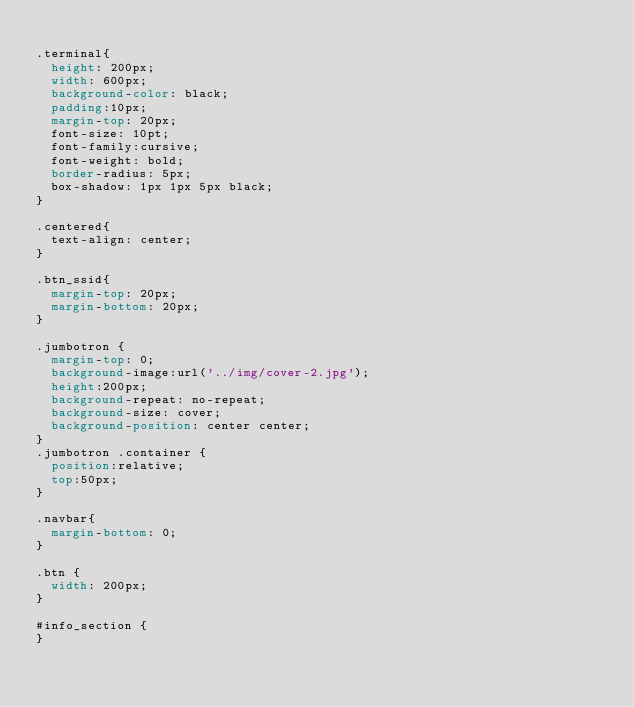Convert code to text. <code><loc_0><loc_0><loc_500><loc_500><_CSS_>
.terminal{
  height: 200px;
  width: 600px;
  background-color: black;
  padding:10px;
  margin-top: 20px;
  font-size: 10pt;
  font-family:cursive;
  font-weight: bold;
  border-radius: 5px;
  box-shadow: 1px 1px 5px black;
}

.centered{
  text-align: center;
}

.btn_ssid{
  margin-top: 20px;
  margin-bottom: 20px;
}

.jumbotron {
  margin-top: 0;
  background-image:url('../img/cover-2.jpg');
  height:200px;
  background-repeat: no-repeat;
  background-size: cover;
  background-position: center center;
}
.jumbotron .container {
  position:relative;
  top:50px;
}

.navbar{
  margin-bottom: 0;
}

.btn {
  width: 200px;
}

#info_section {
}
</code> 